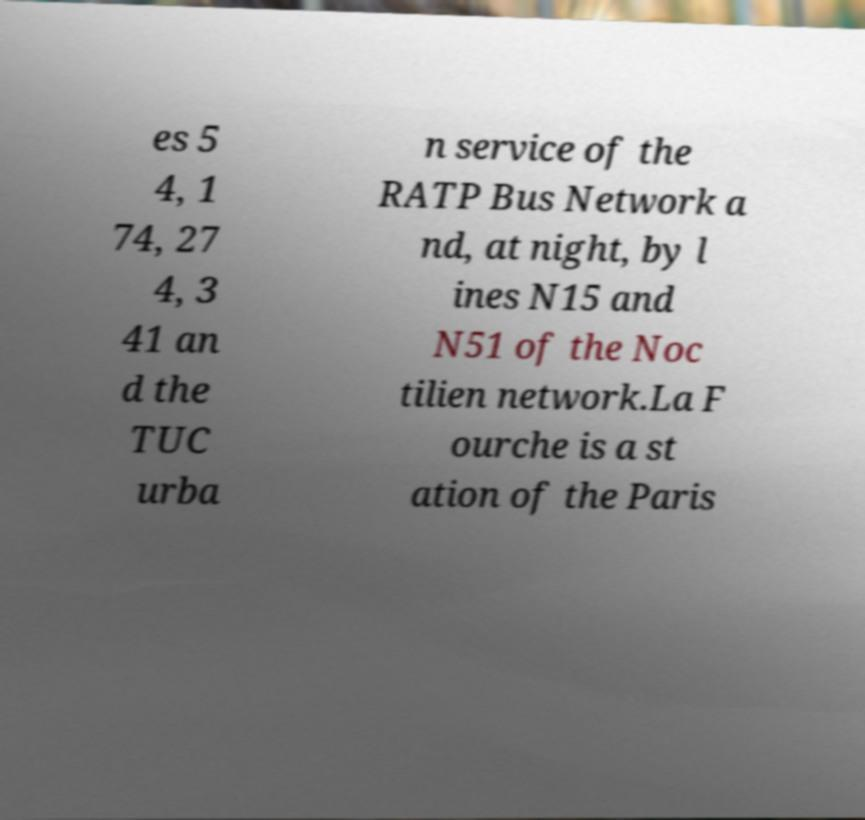Could you extract and type out the text from this image? es 5 4, 1 74, 27 4, 3 41 an d the TUC urba n service of the RATP Bus Network a nd, at night, by l ines N15 and N51 of the Noc tilien network.La F ourche is a st ation of the Paris 